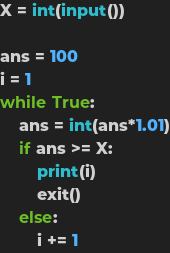Convert code to text. <code><loc_0><loc_0><loc_500><loc_500><_Python_>X = int(input())

ans = 100
i = 1
while True:
    ans = int(ans*1.01)
    if ans >= X:
        print(i)
        exit()
    else:
        i += 1</code> 